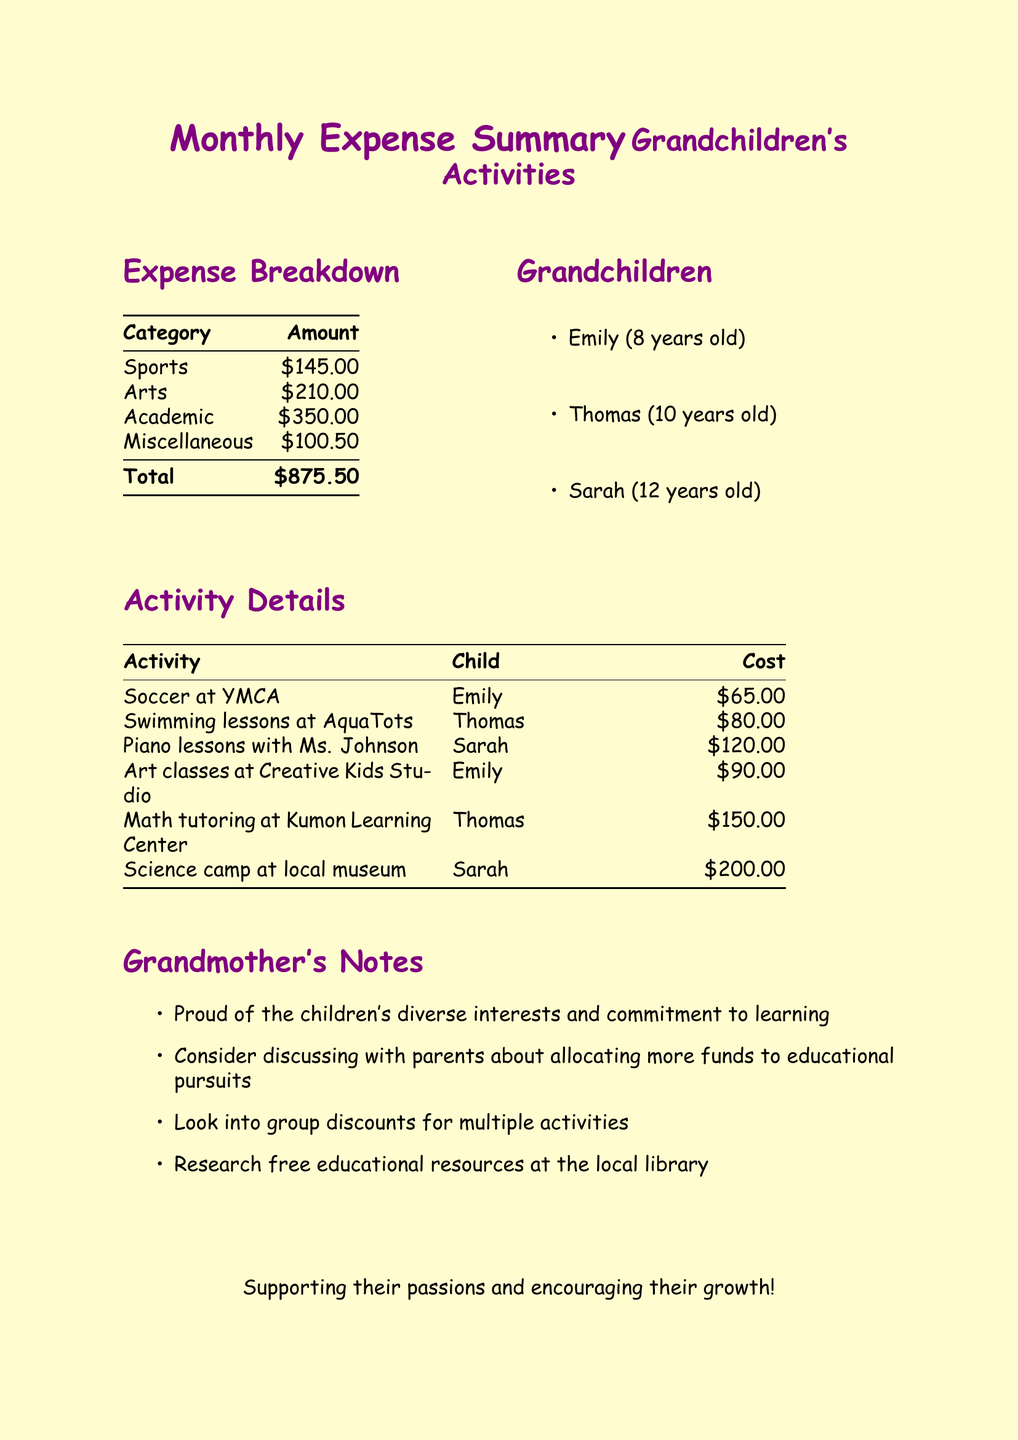What is the total expense for the month? The total expense is provided at the beginning of the document, which includes all categories combined.
Answer: $875.50 How much is spent on Sports activities? The document includes a breakdown of expenses by category and lists the total for Sports activities.
Answer: $145.00 Who has swimming lessons at AquaTots? This detail is specifically mentioned in the activities section, identifying which child participates in swimming lessons.
Answer: Thomas What is the cost of the Science camp at the local museum? The document contains specific costs for each academic activity, including the Science camp.
Answer: $200.00 What is the age of Emily? The age of Emily is listed in the grandchildren section of the document.
Answer: 8 years old What is mentioned in the grandmother's notes about educational resources? The notes contain suggestions for looking into educational resources available to the grandchildren.
Answer: Research free educational resources at the local library How many children are involved in the activities listed? The document provides names and age details for all the grandchildren, summarizing their participation.
Answer: 3 What is the total cost of Arts activities? The total cost for Arts activities is presented in the expenses breakdown section of the document.
Answer: $210.00 